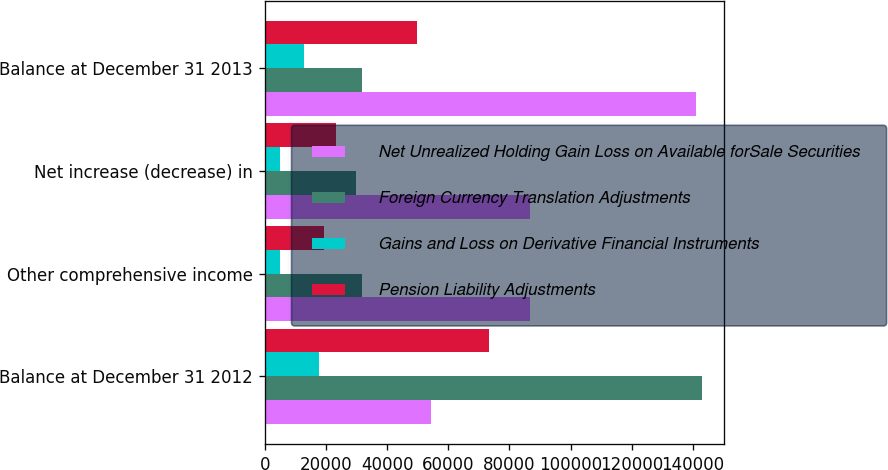Convert chart. <chart><loc_0><loc_0><loc_500><loc_500><stacked_bar_chart><ecel><fcel>Balance at December 31 2012<fcel>Other comprehensive income<fcel>Net increase (decrease) in<fcel>Balance at December 31 2013<nl><fcel>Net Unrealized Holding Gain Loss on Available forSale Securities<fcel>54302<fcel>86690<fcel>86690<fcel>140992<nl><fcel>Foreign Currency Translation Adjustments<fcel>143142<fcel>31687<fcel>29725<fcel>31687<nl><fcel>Gains and Loss on Derivative Financial Instruments<fcel>17822<fcel>5093<fcel>5093<fcel>12729<nl><fcel>Pension Liability Adjustments<fcel>73182<fcel>19478<fcel>23266<fcel>49916<nl></chart> 